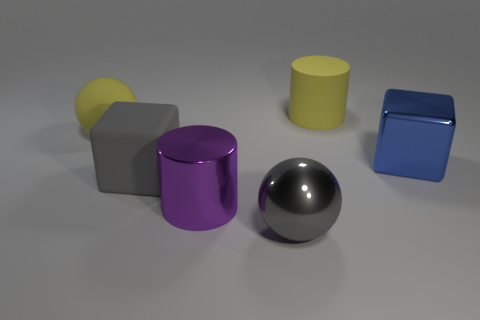Add 1 cylinders. How many objects exist? 7 Subtract all blocks. How many objects are left? 4 Subtract 1 cylinders. How many cylinders are left? 1 Subtract all yellow cylinders. Subtract all green blocks. How many cylinders are left? 1 Subtract all yellow cylinders. How many red spheres are left? 0 Subtract all purple metallic things. Subtract all purple metallic things. How many objects are left? 4 Add 4 big cylinders. How many big cylinders are left? 6 Add 2 big blue metallic blocks. How many big blue metallic blocks exist? 3 Subtract 0 red spheres. How many objects are left? 6 